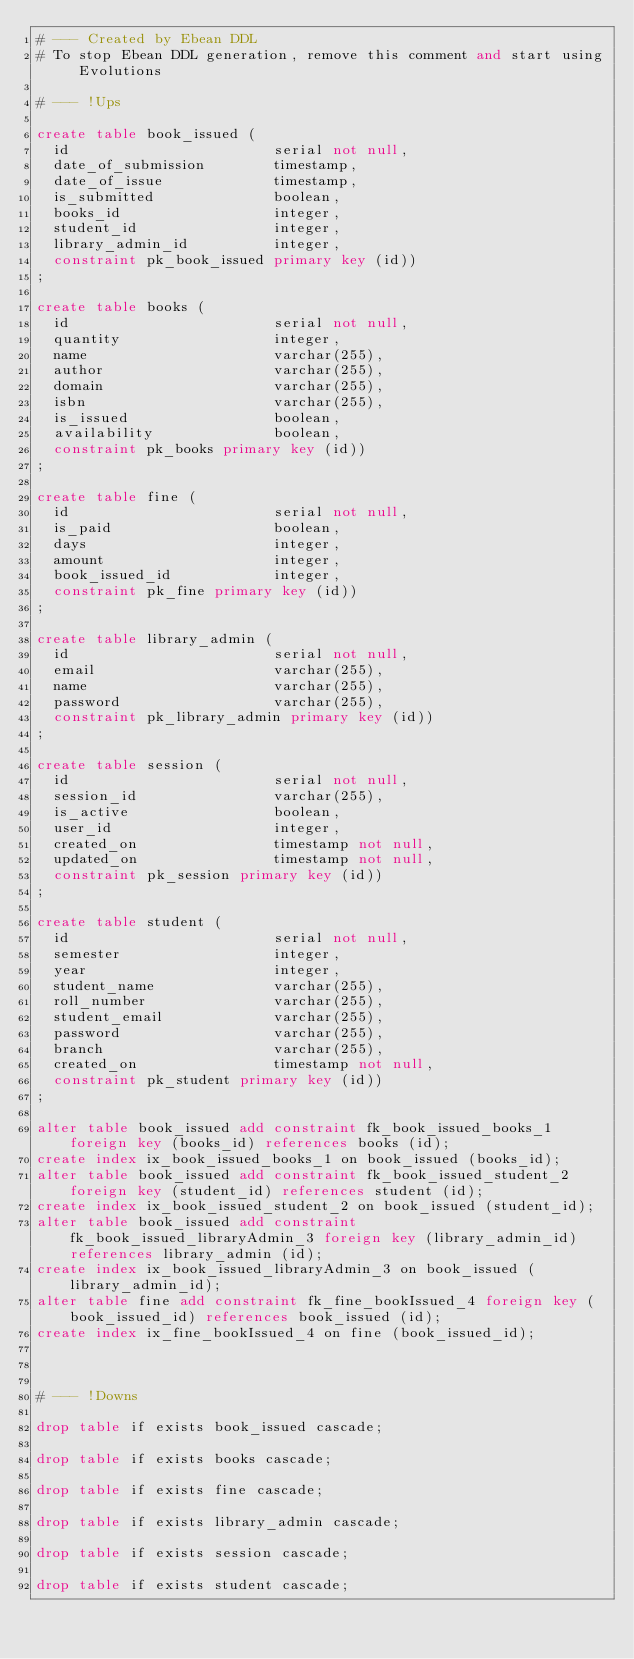<code> <loc_0><loc_0><loc_500><loc_500><_SQL_># --- Created by Ebean DDL
# To stop Ebean DDL generation, remove this comment and start using Evolutions

# --- !Ups

create table book_issued (
  id                        serial not null,
  date_of_submission        timestamp,
  date_of_issue             timestamp,
  is_submitted              boolean,
  books_id                  integer,
  student_id                integer,
  library_admin_id          integer,
  constraint pk_book_issued primary key (id))
;

create table books (
  id                        serial not null,
  quantity                  integer,
  name                      varchar(255),
  author                    varchar(255),
  domain                    varchar(255),
  isbn                      varchar(255),
  is_issued                 boolean,
  availability              boolean,
  constraint pk_books primary key (id))
;

create table fine (
  id                        serial not null,
  is_paid                   boolean,
  days                      integer,
  amount                    integer,
  book_issued_id            integer,
  constraint pk_fine primary key (id))
;

create table library_admin (
  id                        serial not null,
  email                     varchar(255),
  name                      varchar(255),
  password                  varchar(255),
  constraint pk_library_admin primary key (id))
;

create table session (
  id                        serial not null,
  session_id                varchar(255),
  is_active                 boolean,
  user_id                   integer,
  created_on                timestamp not null,
  updated_on                timestamp not null,
  constraint pk_session primary key (id))
;

create table student (
  id                        serial not null,
  semester                  integer,
  year                      integer,
  student_name              varchar(255),
  roll_number               varchar(255),
  student_email             varchar(255),
  password                  varchar(255),
  branch                    varchar(255),
  created_on                timestamp not null,
  constraint pk_student primary key (id))
;

alter table book_issued add constraint fk_book_issued_books_1 foreign key (books_id) references books (id);
create index ix_book_issued_books_1 on book_issued (books_id);
alter table book_issued add constraint fk_book_issued_student_2 foreign key (student_id) references student (id);
create index ix_book_issued_student_2 on book_issued (student_id);
alter table book_issued add constraint fk_book_issued_libraryAdmin_3 foreign key (library_admin_id) references library_admin (id);
create index ix_book_issued_libraryAdmin_3 on book_issued (library_admin_id);
alter table fine add constraint fk_fine_bookIssued_4 foreign key (book_issued_id) references book_issued (id);
create index ix_fine_bookIssued_4 on fine (book_issued_id);



# --- !Downs

drop table if exists book_issued cascade;

drop table if exists books cascade;

drop table if exists fine cascade;

drop table if exists library_admin cascade;

drop table if exists session cascade;

drop table if exists student cascade;

</code> 